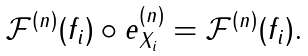<formula> <loc_0><loc_0><loc_500><loc_500>\begin{array} { c } \mathcal { F } ^ { ( n ) } ( f _ { i } ) \circ e ^ { ( n ) } _ { X _ { i } } = \mathcal { F } ^ { ( n ) } ( f _ { i } ) . \end{array}</formula> 